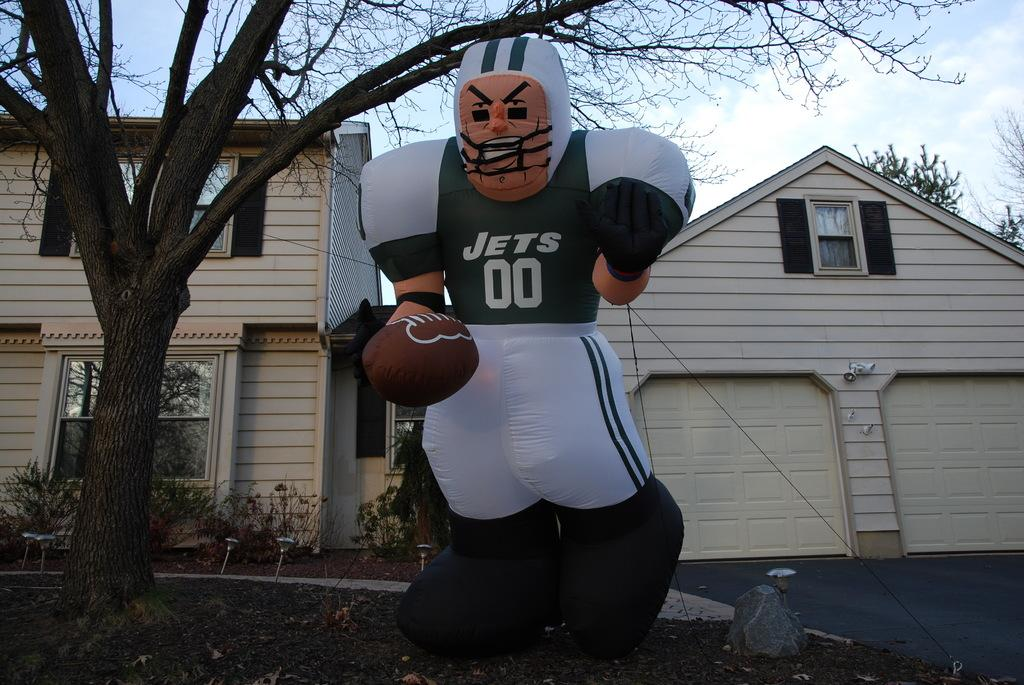<image>
Render a clear and concise summary of the photo. a Jets blow up object with the numbers 00 on it 